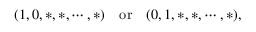Convert formula to latex. <formula><loc_0><loc_0><loc_500><loc_500>( 1 , 0 , * , * , \cdots , * ) \quad o r \quad ( 0 , 1 , * , * , \cdots , * ) ,</formula> 